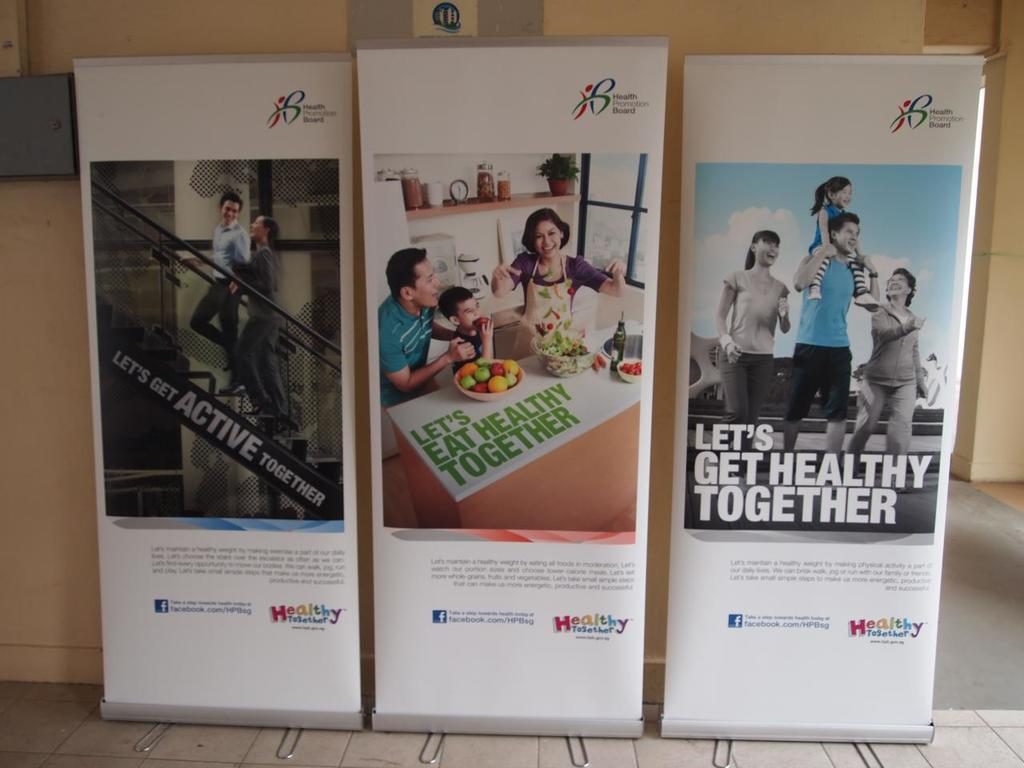<image>
Provide a brief description of the given image. Three photos on white showing people getting healthy and active. 